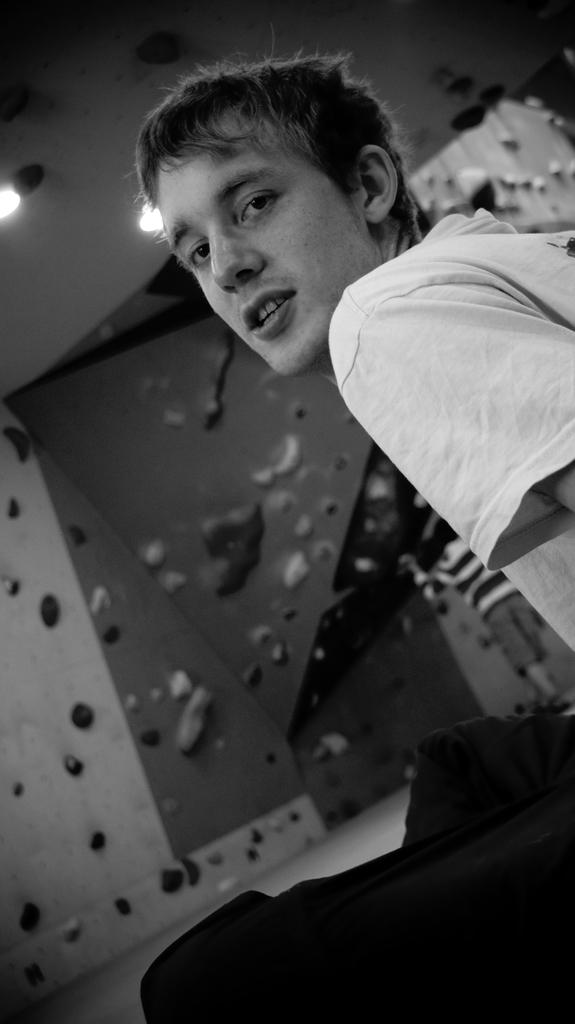What is the man in the image doing? The facts provided do not specify what the man is doing, only that he is standing. What is the man wearing in the image? The man is wearing a T-shirt in the image. What can be seen in the background of the image? There is a wall visible in the background. What is attached to the wall in the image? The facts provided do not specify what is attached to the wall. What can be seen on the ceiling in the image? There are lights visible on the ceiling in the image. What type of lumber is the man holding in the image? There is no lumber present in the image; the man is only wearing a T-shirt and standing. What instrument is the man playing in the image? There is no instrument present in the image; the man is only standing and wearing a T-shirt. 